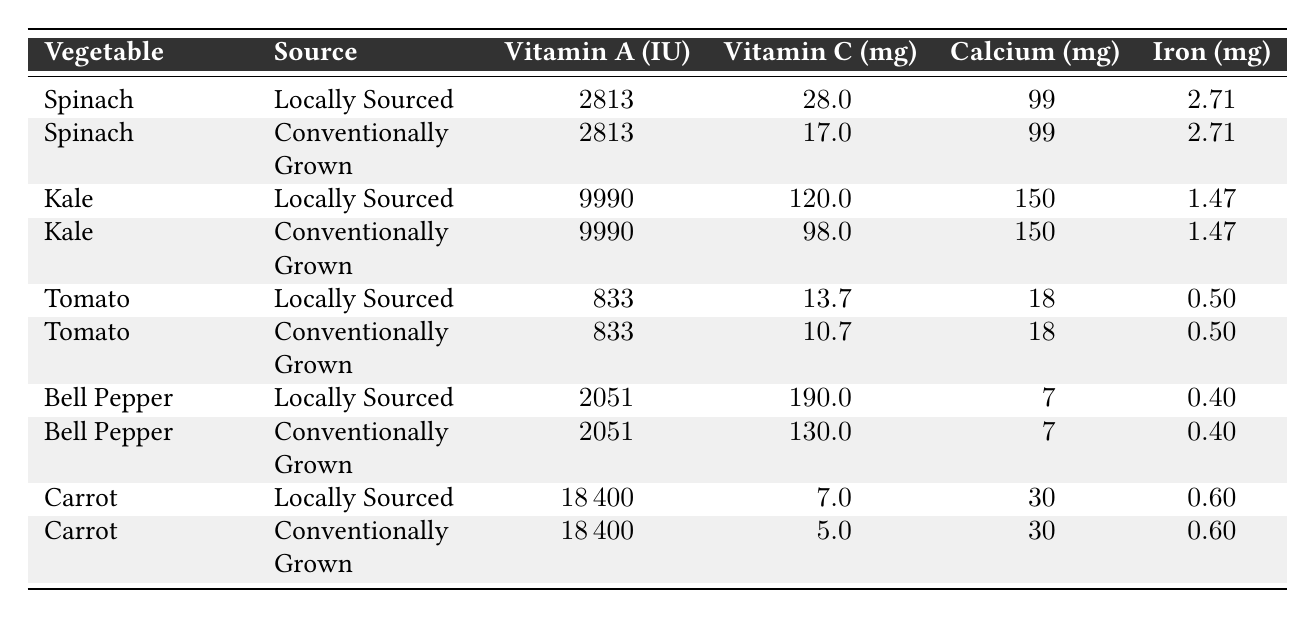What is the Vitamin C content of locally sourced spinach? The table shows that for locally sourced spinach, the Vitamin C content is 28 mg.
Answer: 28 mg What is the Iron content of conventionally grown kale? Looking at the table, conventionally grown kale has an Iron content of 1.47 mg.
Answer: 1.47 mg Which vegetable has the highest Vitamin A content? By comparing the Vitamin A content across all vegetables, carrots have the highest at 18400 IU.
Answer: 18400 IU Does conventionally grown spinach have more Vitamin C than conventionally grown tomato? From the table, conventionally grown spinach has 17 mg of Vitamin C, while conventionally grown tomato has 10.7 mg, so spinach has more.
Answer: Yes What is the difference in Calcium content between locally sourced and conventionally grown carrots? The Calcium content for both locally sourced and conventionally grown carrots is the same at 30 mg, so the difference is 0 mg.
Answer: 0 mg What is the average Vitamin C content of locally sourced vegetables in the table? The Vitamin C content for locally sourced vegetables is 28 mg (spinach) + 120 mg (kale) + 13.7 mg (tomato) + 190 mg (bell pepper) + 7 mg (carrot) = 358.7 mg. Dividing by 5 gives an average of 71.74 mg.
Answer: 71.74 mg Is the Iron content of locally sourced bell pepper higher than that of conventionally grown bell pepper? The Iron content for both locally sourced and conventionally grown bell pepper is the same at 0.40 mg, so it is not higher.
Answer: No What is the total Vitamin A content of conventionally grown vegetables in the table? Summing up the Vitamin A contents of conventionally grown spinach (2813 IU), kale (9990 IU), tomato (833 IU), bell pepper (2051 IU), and carrot (18400 IU) results in a total of 28877 IU.
Answer: 28877 IU Which locally sourced vegetable has the highest Vitamin C content? The table indicates that locally sourced kale has the highest Vitamin C content at 120 mg.
Answer: 120 mg What is the ratio of Iron content between locally sourced carrots and conventionally grown carrots? Both locally sourced and conventionally grown carrots have Iron content of 0.60 mg, so the ratio is 0.60 : 0.60, which simplifies to 1:1.
Answer: 1:1 